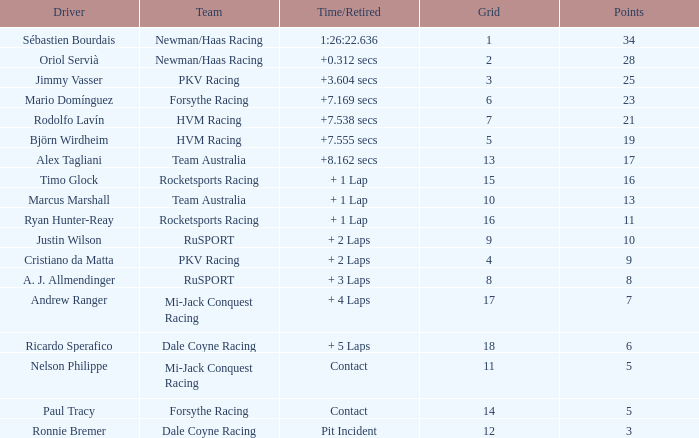What is the name of the motorist with 6 points? Ricardo Sperafico. Would you mind parsing the complete table? {'header': ['Driver', 'Team', 'Time/Retired', 'Grid', 'Points'], 'rows': [['Sébastien Bourdais', 'Newman/Haas Racing', '1:26:22.636', '1', '34'], ['Oriol Servià', 'Newman/Haas Racing', '+0.312 secs', '2', '28'], ['Jimmy Vasser', 'PKV Racing', '+3.604 secs', '3', '25'], ['Mario Domínguez', 'Forsythe Racing', '+7.169 secs', '6', '23'], ['Rodolfo Lavín', 'HVM Racing', '+7.538 secs', '7', '21'], ['Björn Wirdheim', 'HVM Racing', '+7.555 secs', '5', '19'], ['Alex Tagliani', 'Team Australia', '+8.162 secs', '13', '17'], ['Timo Glock', 'Rocketsports Racing', '+ 1 Lap', '15', '16'], ['Marcus Marshall', 'Team Australia', '+ 1 Lap', '10', '13'], ['Ryan Hunter-Reay', 'Rocketsports Racing', '+ 1 Lap', '16', '11'], ['Justin Wilson', 'RuSPORT', '+ 2 Laps', '9', '10'], ['Cristiano da Matta', 'PKV Racing', '+ 2 Laps', '4', '9'], ['A. J. Allmendinger', 'RuSPORT', '+ 3 Laps', '8', '8'], ['Andrew Ranger', 'Mi-Jack Conquest Racing', '+ 4 Laps', '17', '7'], ['Ricardo Sperafico', 'Dale Coyne Racing', '+ 5 Laps', '18', '6'], ['Nelson Philippe', 'Mi-Jack Conquest Racing', 'Contact', '11', '5'], ['Paul Tracy', 'Forsythe Racing', 'Contact', '14', '5'], ['Ronnie Bremer', 'Dale Coyne Racing', 'Pit Incident', '12', '3']]} 